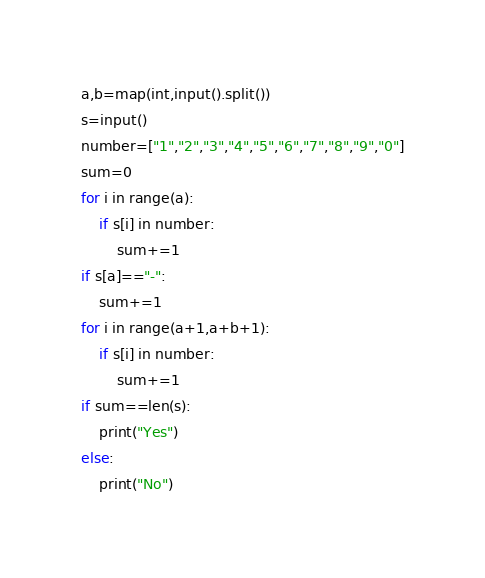Convert code to text. <code><loc_0><loc_0><loc_500><loc_500><_Python_>a,b=map(int,input().split())
s=input()
number=["1","2","3","4","5","6","7","8","9","0"]
sum=0
for i in range(a):
    if s[i] in number:
        sum+=1
if s[a]=="-":
    sum+=1
for i in range(a+1,a+b+1):
    if s[i] in number:
        sum+=1
if sum==len(s):
    print("Yes")
else:
    print("No")</code> 